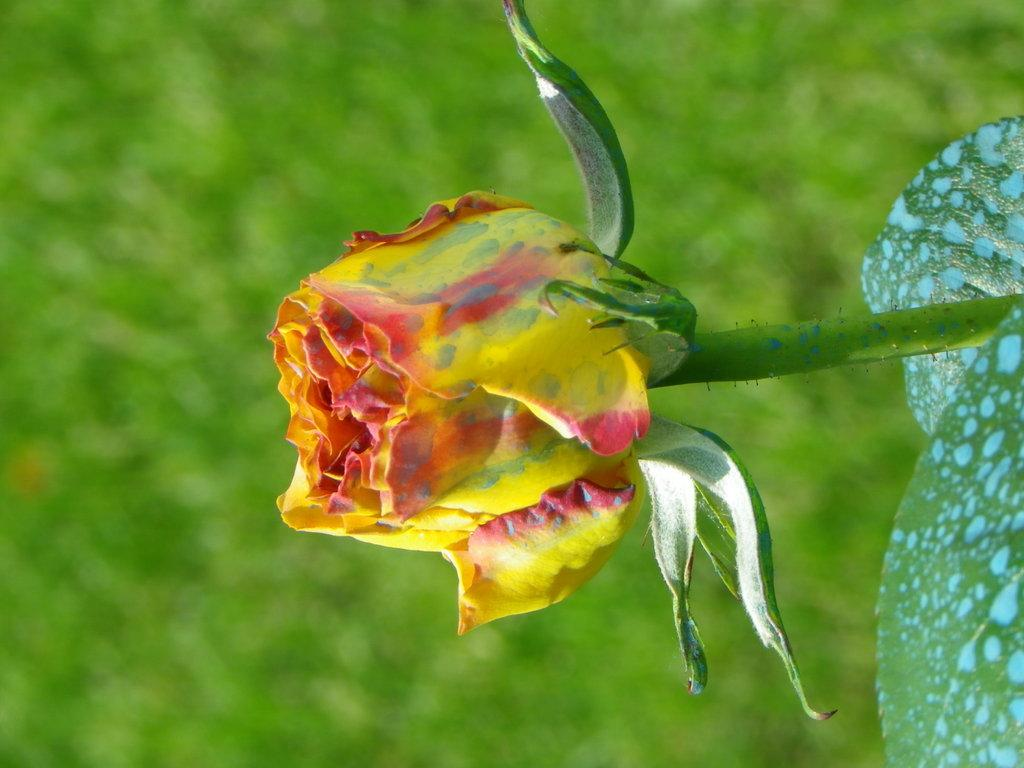Where was the image taken? The image was taken outdoors. What can be seen on the left side of the image? There is a ground with grass on the left side of the image. What is present on the right side of the image? There is a plant with a flower on the right side of the image. Is there a mailbox visible in the image? No, there is no mailbox present in the image. What type of box can be seen holding the flower on the plant? There is no box holding the flower on the plant in the image; the flower is directly attached to the plant. 